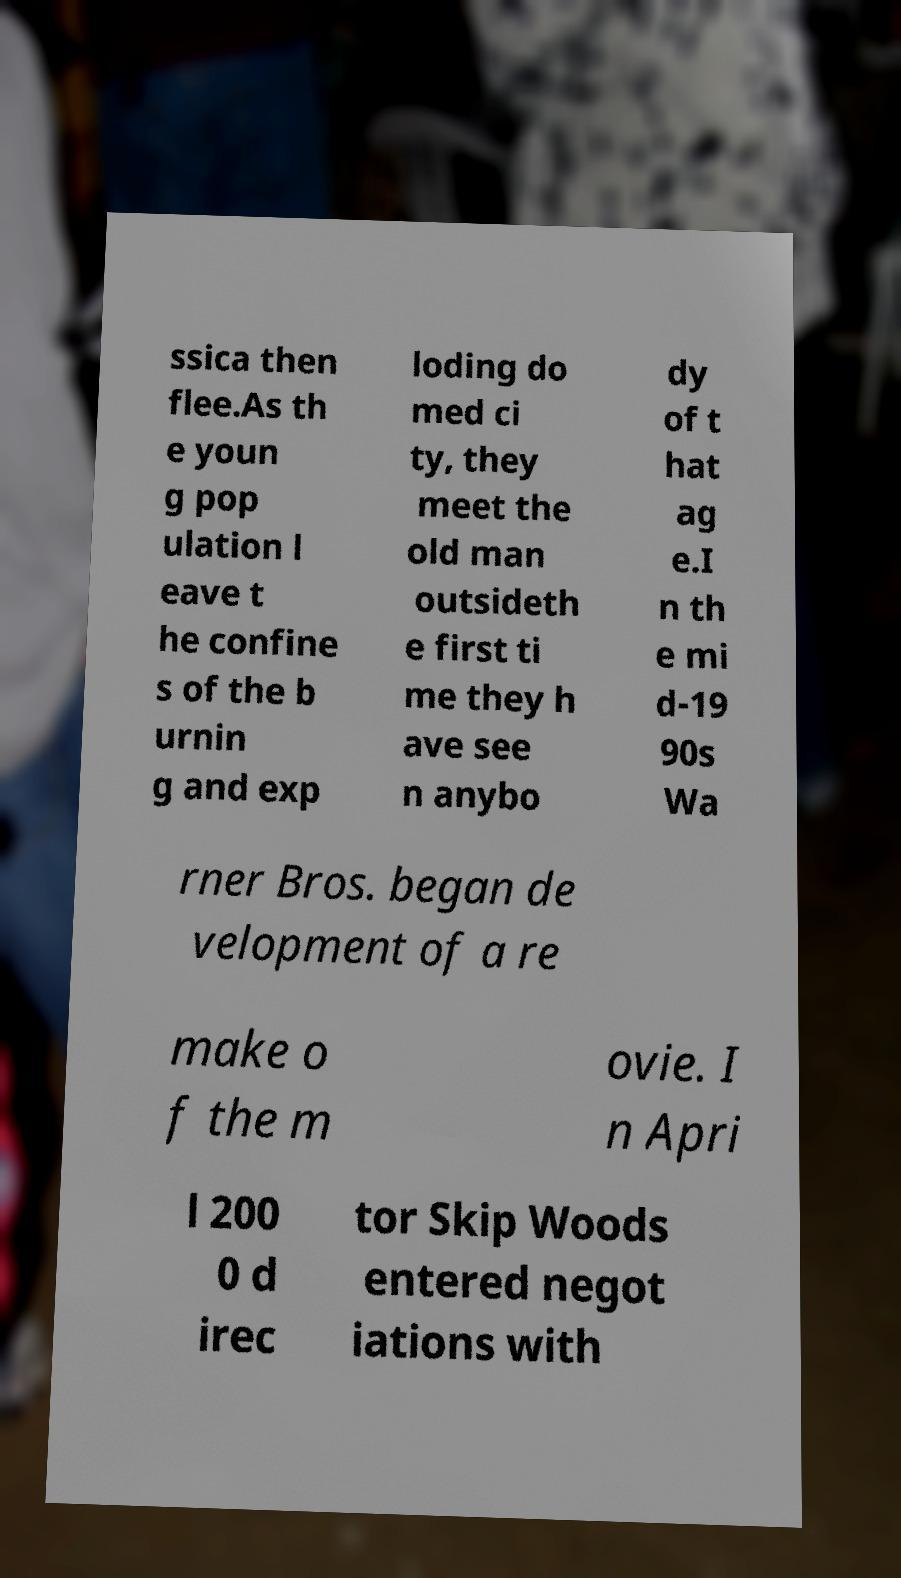Could you extract and type out the text from this image? ssica then flee.As th e youn g pop ulation l eave t he confine s of the b urnin g and exp loding do med ci ty, they meet the old man outsideth e first ti me they h ave see n anybo dy of t hat ag e.I n th e mi d-19 90s Wa rner Bros. began de velopment of a re make o f the m ovie. I n Apri l 200 0 d irec tor Skip Woods entered negot iations with 